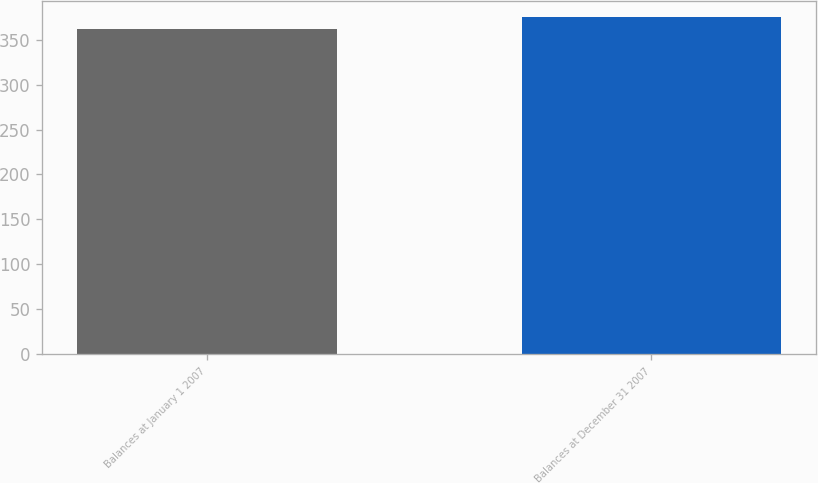Convert chart to OTSL. <chart><loc_0><loc_0><loc_500><loc_500><bar_chart><fcel>Balances at January 1 2007<fcel>Balances at December 31 2007<nl><fcel>361.9<fcel>374.7<nl></chart> 